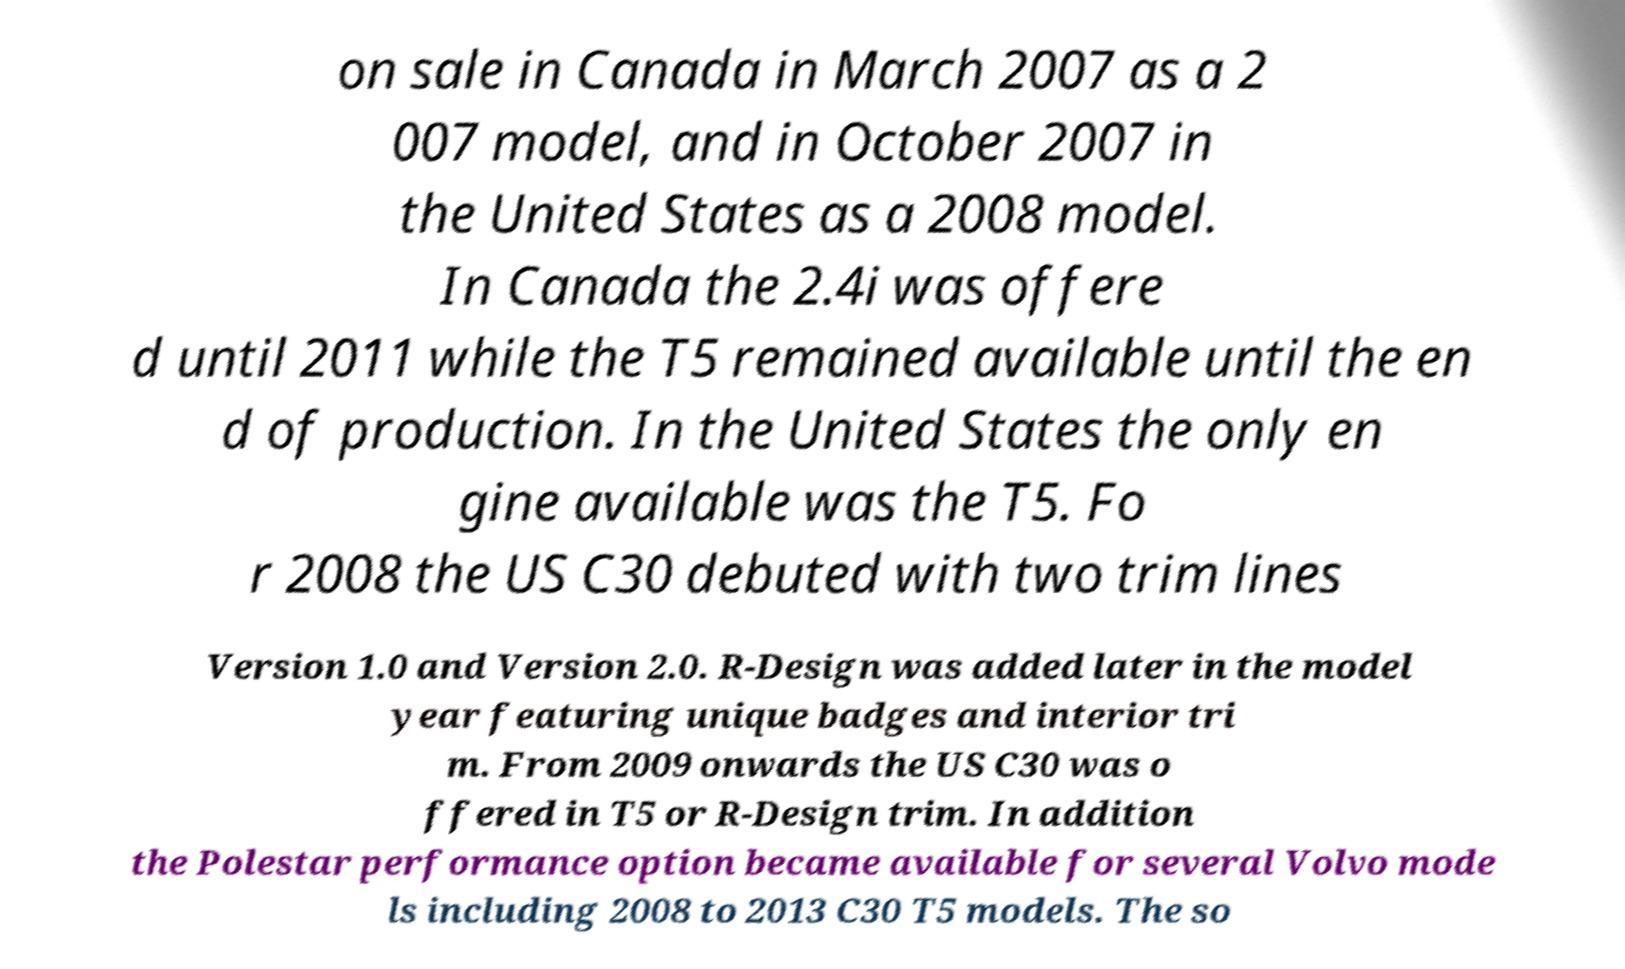There's text embedded in this image that I need extracted. Can you transcribe it verbatim? on sale in Canada in March 2007 as a 2 007 model, and in October 2007 in the United States as a 2008 model. In Canada the 2.4i was offere d until 2011 while the T5 remained available until the en d of production. In the United States the only en gine available was the T5. Fo r 2008 the US C30 debuted with two trim lines Version 1.0 and Version 2.0. R-Design was added later in the model year featuring unique badges and interior tri m. From 2009 onwards the US C30 was o ffered in T5 or R-Design trim. In addition the Polestar performance option became available for several Volvo mode ls including 2008 to 2013 C30 T5 models. The so 